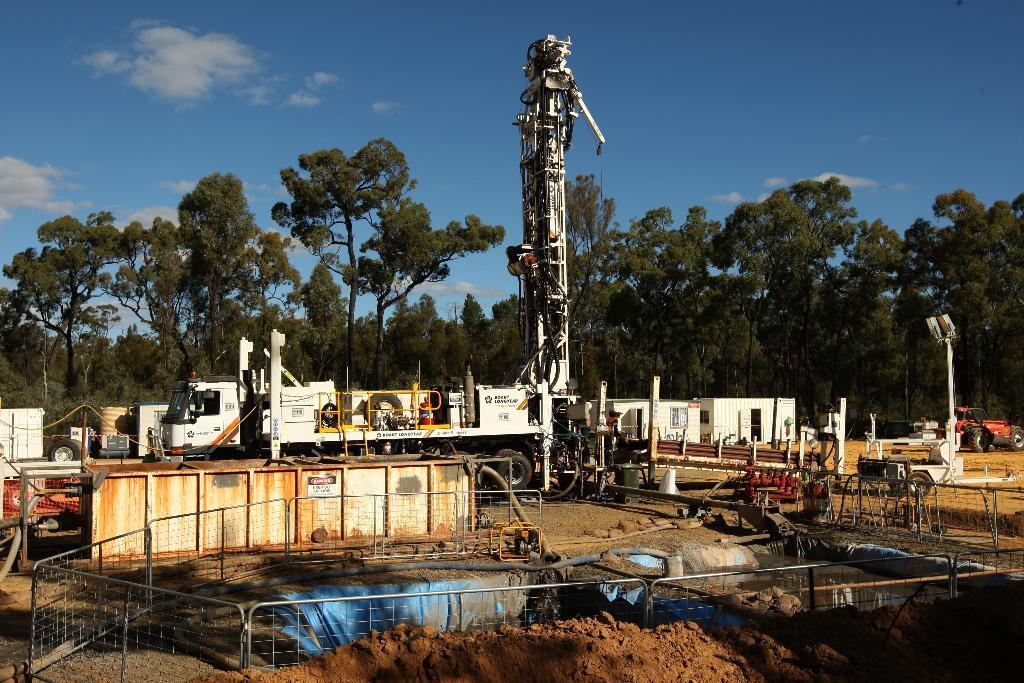What is located in the foreground of the image? There is a fence, mud, metal rods, and vehicles visible in the foreground of the image. What type of vegetation can be seen in the background of the image? There are trees in the background of the image. What is visible in the sky in the background of the image? The sky is visible in the background of the image. Can you tell if the image was taken during the day or night? The image was likely taken during the day, as there is no indication of darkness or artificial lighting. How many bananas are hanging from the trees in the background of the image? There are no bananas visible in the image; only trees are present in the background. Can you tell if there are any yaks grazing in the foreground of the image? There are no yaks present in the image; the foreground features a fence, mud, metal rods, and vehicles. 